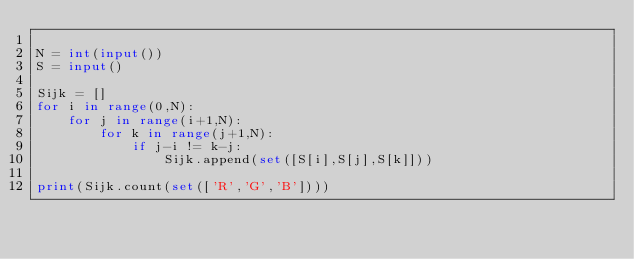Convert code to text. <code><loc_0><loc_0><loc_500><loc_500><_Python_>
N = int(input())
S = input()

Sijk = []
for i in range(0,N):
    for j in range(i+1,N):
        for k in range(j+1,N):
            if j-i != k-j:
                Sijk.append(set([S[i],S[j],S[k]]))

print(Sijk.count(set(['R','G','B'])))

</code> 